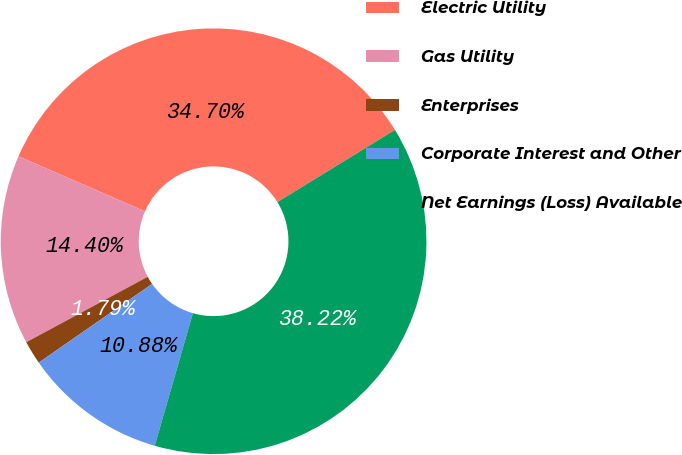Convert chart to OTSL. <chart><loc_0><loc_0><loc_500><loc_500><pie_chart><fcel>Electric Utility<fcel>Gas Utility<fcel>Enterprises<fcel>Corporate Interest and Other<fcel>Net Earnings (Loss) Available<nl><fcel>34.7%<fcel>14.4%<fcel>1.79%<fcel>10.88%<fcel>38.22%<nl></chart> 